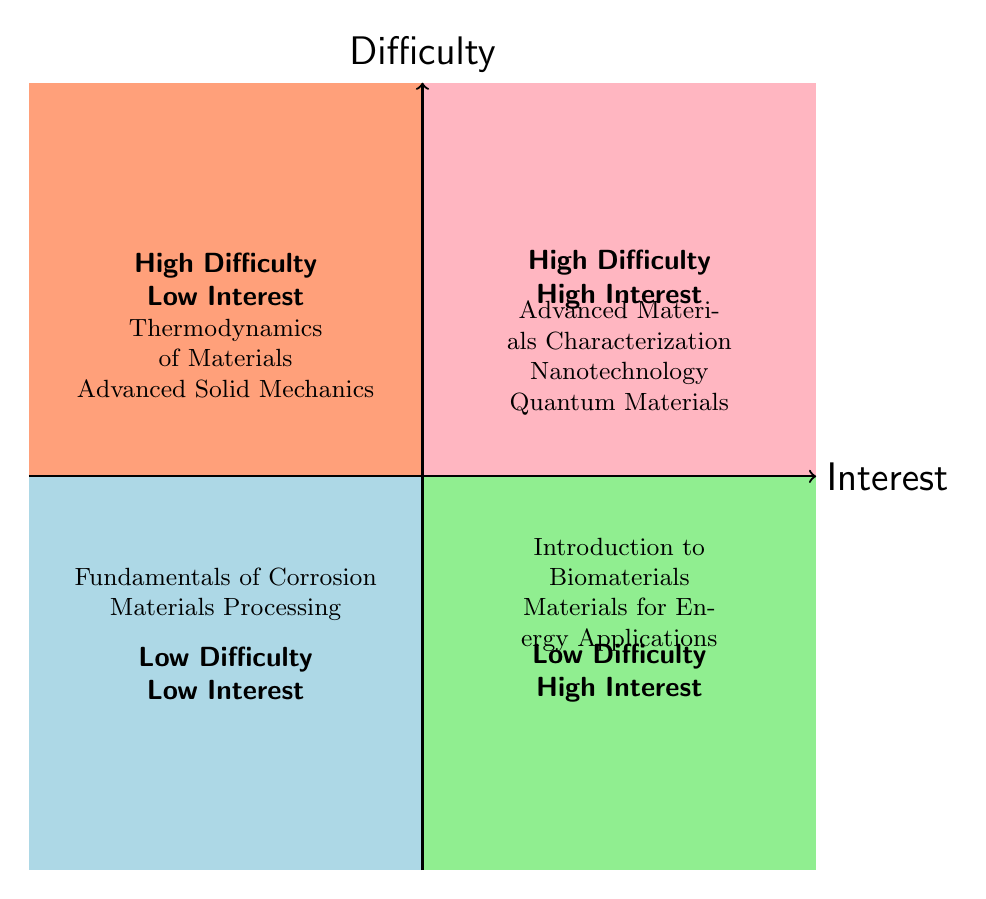What courses fall under high difficulty and high interest? The courses that are categorized in the "High Difficulty - High Interest" quadrant of the chart are listed clearly within that section. They include: Advanced Materials Characterization, Nanotechnology, and Quantum Materials.
Answer: Advanced Materials Characterization, Nanotechnology, Quantum Materials How many courses are in the low difficulty and low interest quadrant? In the "Low Difficulty - Low Interest" quadrant, there are two courses listed: Fundamentals of Corrosion and Materials Processing. Thus, the total count is derived by simply counting the entries.
Answer: 2 Which quadrant contains "Thermodynamics of Materials"? "Thermodynamics of Materials" is located in the quadrant labeled "High Difficulty - Low Interest." This is determined by locating the course within the diagram's respective areas.
Answer: High Difficulty - Low Interest What is the relationship between course difficulty and student interest for "Introduction to Biomaterials"? "Introduction to Biomaterials" is positioned in the "Low Difficulty - High Interest" quadrant, indicating that it has low academic difficulty while maintaining high interest among students.
Answer: Low Difficulty - High Interest Name one course that is both high difficulty and low interest. The course that fits into the "High Difficulty - Low Interest" category is identified clearly in that quadrant. In this case, one of the courses listed is Advanced Solid Mechanics.
Answer: Advanced Solid Mechanics How many courses are listed in the high difficulty categories? Both the "High Difficulty - High Interest" and "High Difficulty - Low Interest" quadrants must be combined to find the total courses. The high difficulty category has three courses from one quadrant and two from another, resulting in a total of five courses.
Answer: 5 Identify a course that is categorized as low difficulty and high interest. The course "Materials for Energy Applications" is situated within the "Low Difficulty - High Interest" quadrant, making it an appropriate answer when asked to identify one from that category.
Answer: Materials for Energy Applications Which quadrant represents low difficulty and high interest courses? The quadrant labeled "Low Difficulty - High Interest" encompasses courses like "Introduction to Biomaterials" and "Materials for Energy Applications," which clearly represents that category.
Answer: Low Difficulty - High Interest 